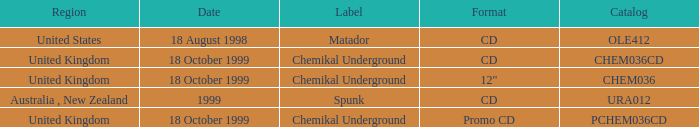What date is associated with the Spunk label? 1999.0. 